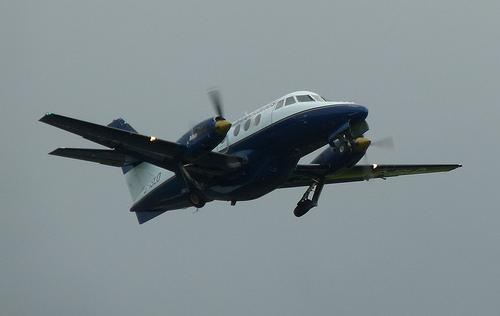How many wheels are there?
Give a very brief answer. 3. How many windows are showing?
Give a very brief answer. 7. 